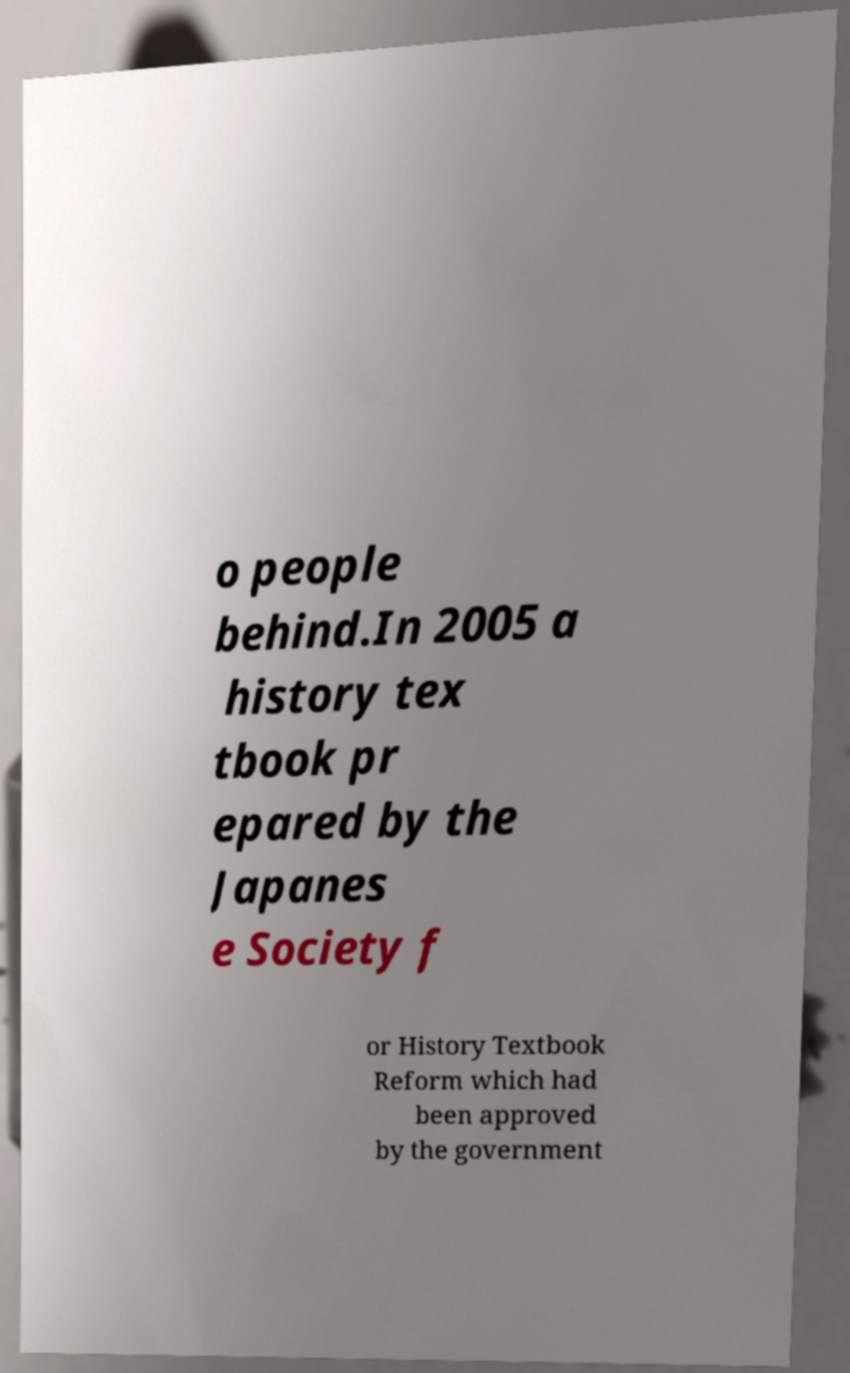What messages or text are displayed in this image? I need them in a readable, typed format. o people behind.In 2005 a history tex tbook pr epared by the Japanes e Society f or History Textbook Reform which had been approved by the government 